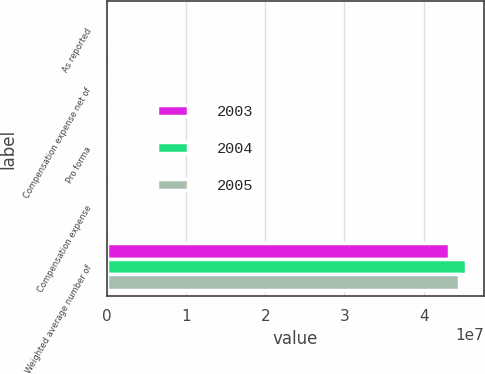Convert chart to OTSL. <chart><loc_0><loc_0><loc_500><loc_500><stacked_bar_chart><ecel><fcel>As reported<fcel>Compensation expense net of<fcel>Pro forma<fcel>Compensation expense<fcel>Weighted average number of<nl><fcel>2003<fcel>108902<fcel>6277<fcel>102625<fcel>0.15<fcel>4.31221e+07<nl><fcel>2004<fcel>107957<fcel>7290<fcel>100667<fcel>0.16<fcel>4.52812e+07<nl><fcel>2005<fcel>95838<fcel>6748<fcel>89090<fcel>0.15<fcel>4.45088e+07<nl></chart> 